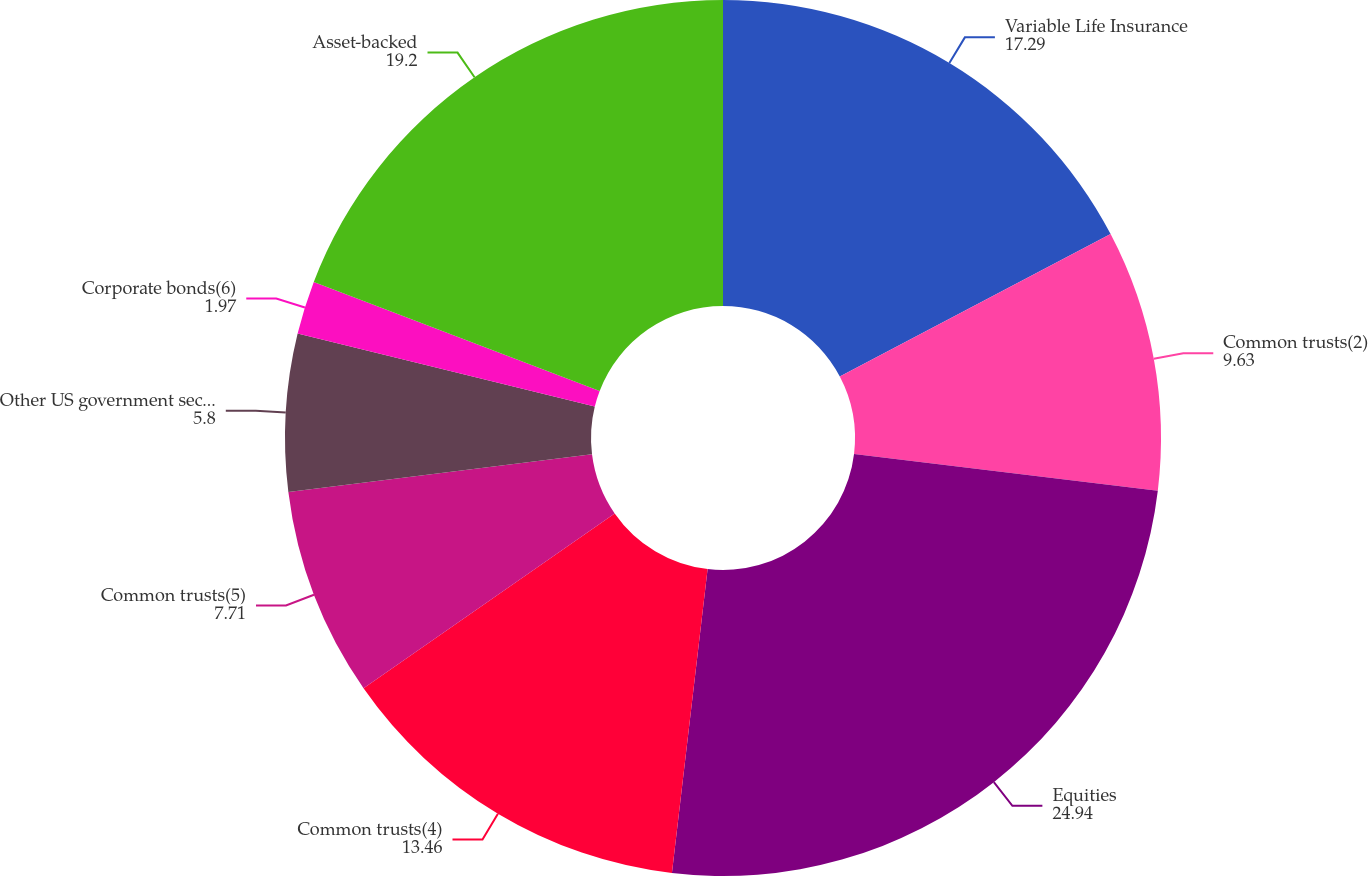<chart> <loc_0><loc_0><loc_500><loc_500><pie_chart><fcel>Variable Life Insurance<fcel>Common trusts(2)<fcel>Equities<fcel>Common trusts(4)<fcel>Common trusts(5)<fcel>Other US government securities<fcel>Corporate bonds(6)<fcel>Asset-backed<nl><fcel>17.29%<fcel>9.63%<fcel>24.94%<fcel>13.46%<fcel>7.71%<fcel>5.8%<fcel>1.97%<fcel>19.2%<nl></chart> 